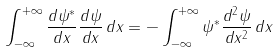<formula> <loc_0><loc_0><loc_500><loc_500>\int _ { - \infty } ^ { + \infty } \frac { d \psi ^ { * } } { d x } \frac { d \psi } { d x } \, d x = - \int _ { - \infty } ^ { + \infty } \psi ^ { * } \frac { d ^ { 2 } \psi } { d x ^ { 2 } } \, d x</formula> 